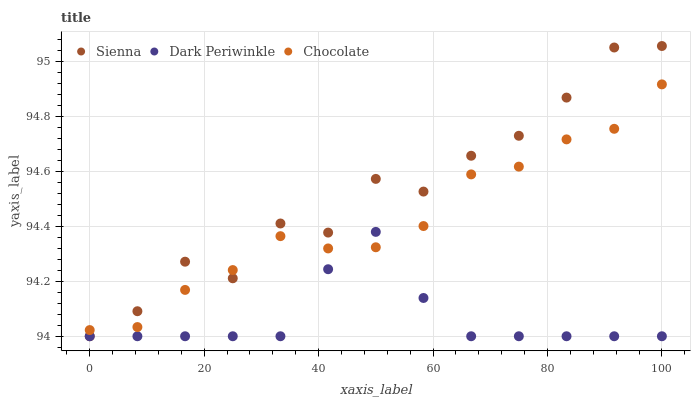Does Dark Periwinkle have the minimum area under the curve?
Answer yes or no. Yes. Does Sienna have the maximum area under the curve?
Answer yes or no. Yes. Does Chocolate have the minimum area under the curve?
Answer yes or no. No. Does Chocolate have the maximum area under the curve?
Answer yes or no. No. Is Dark Periwinkle the smoothest?
Answer yes or no. Yes. Is Sienna the roughest?
Answer yes or no. Yes. Is Chocolate the smoothest?
Answer yes or no. No. Is Chocolate the roughest?
Answer yes or no. No. Does Sienna have the lowest value?
Answer yes or no. Yes. Does Chocolate have the lowest value?
Answer yes or no. No. Does Sienna have the highest value?
Answer yes or no. Yes. Does Chocolate have the highest value?
Answer yes or no. No. Does Dark Periwinkle intersect Sienna?
Answer yes or no. Yes. Is Dark Periwinkle less than Sienna?
Answer yes or no. No. Is Dark Periwinkle greater than Sienna?
Answer yes or no. No. 